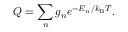Convert formula to latex. <formula><loc_0><loc_0><loc_500><loc_500>Q = \sum _ { n } g _ { n } e ^ { - E _ { n } / k _ { B } T } .</formula> 